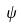<formula> <loc_0><loc_0><loc_500><loc_500>\psi</formula> 